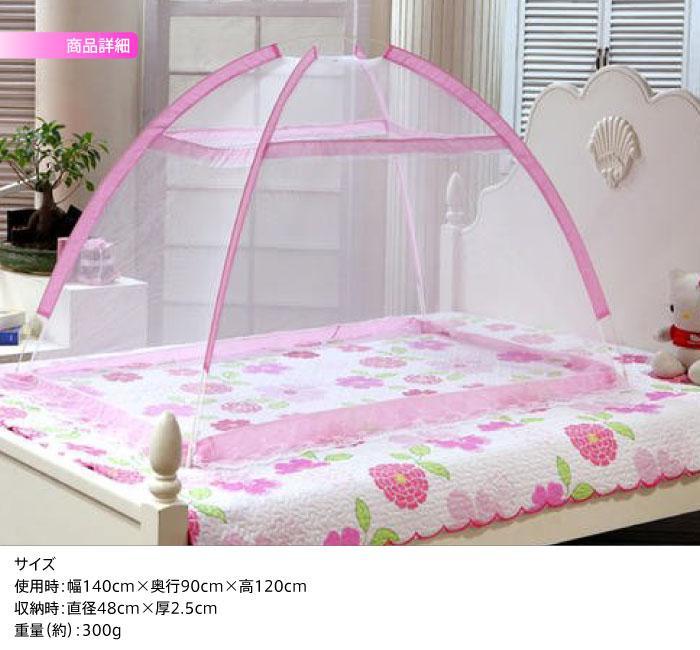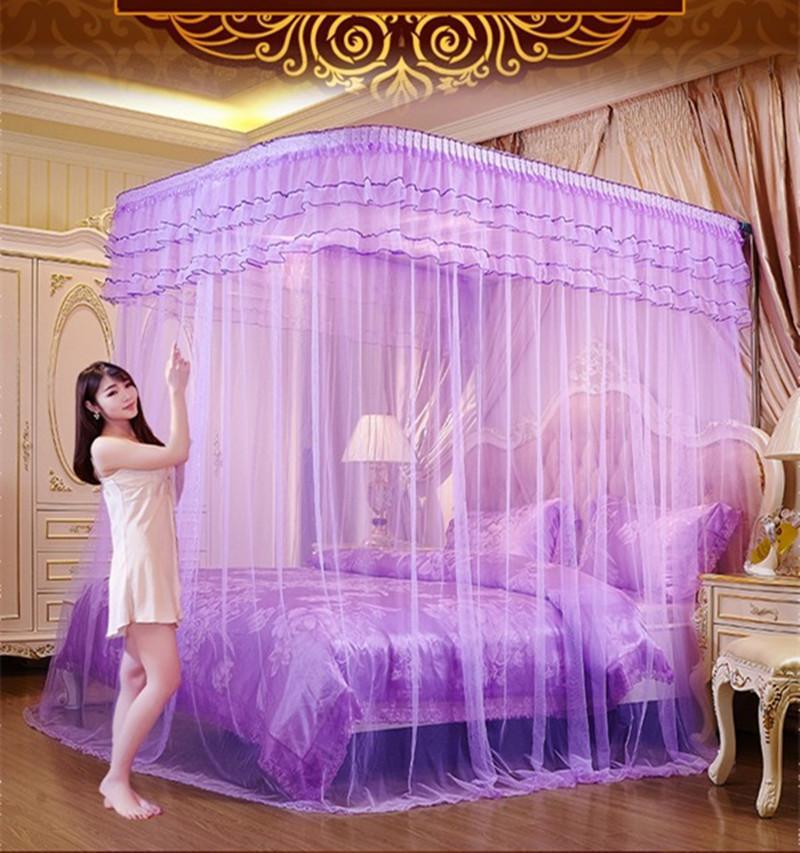The first image is the image on the left, the second image is the image on the right. Assess this claim about the two images: "One of the beds is a bunk bed.". Correct or not? Answer yes or no. No. The first image is the image on the left, the second image is the image on the right. Examine the images to the left and right. Is the description "There are two canopies with at least one that is purple." accurate? Answer yes or no. Yes. 